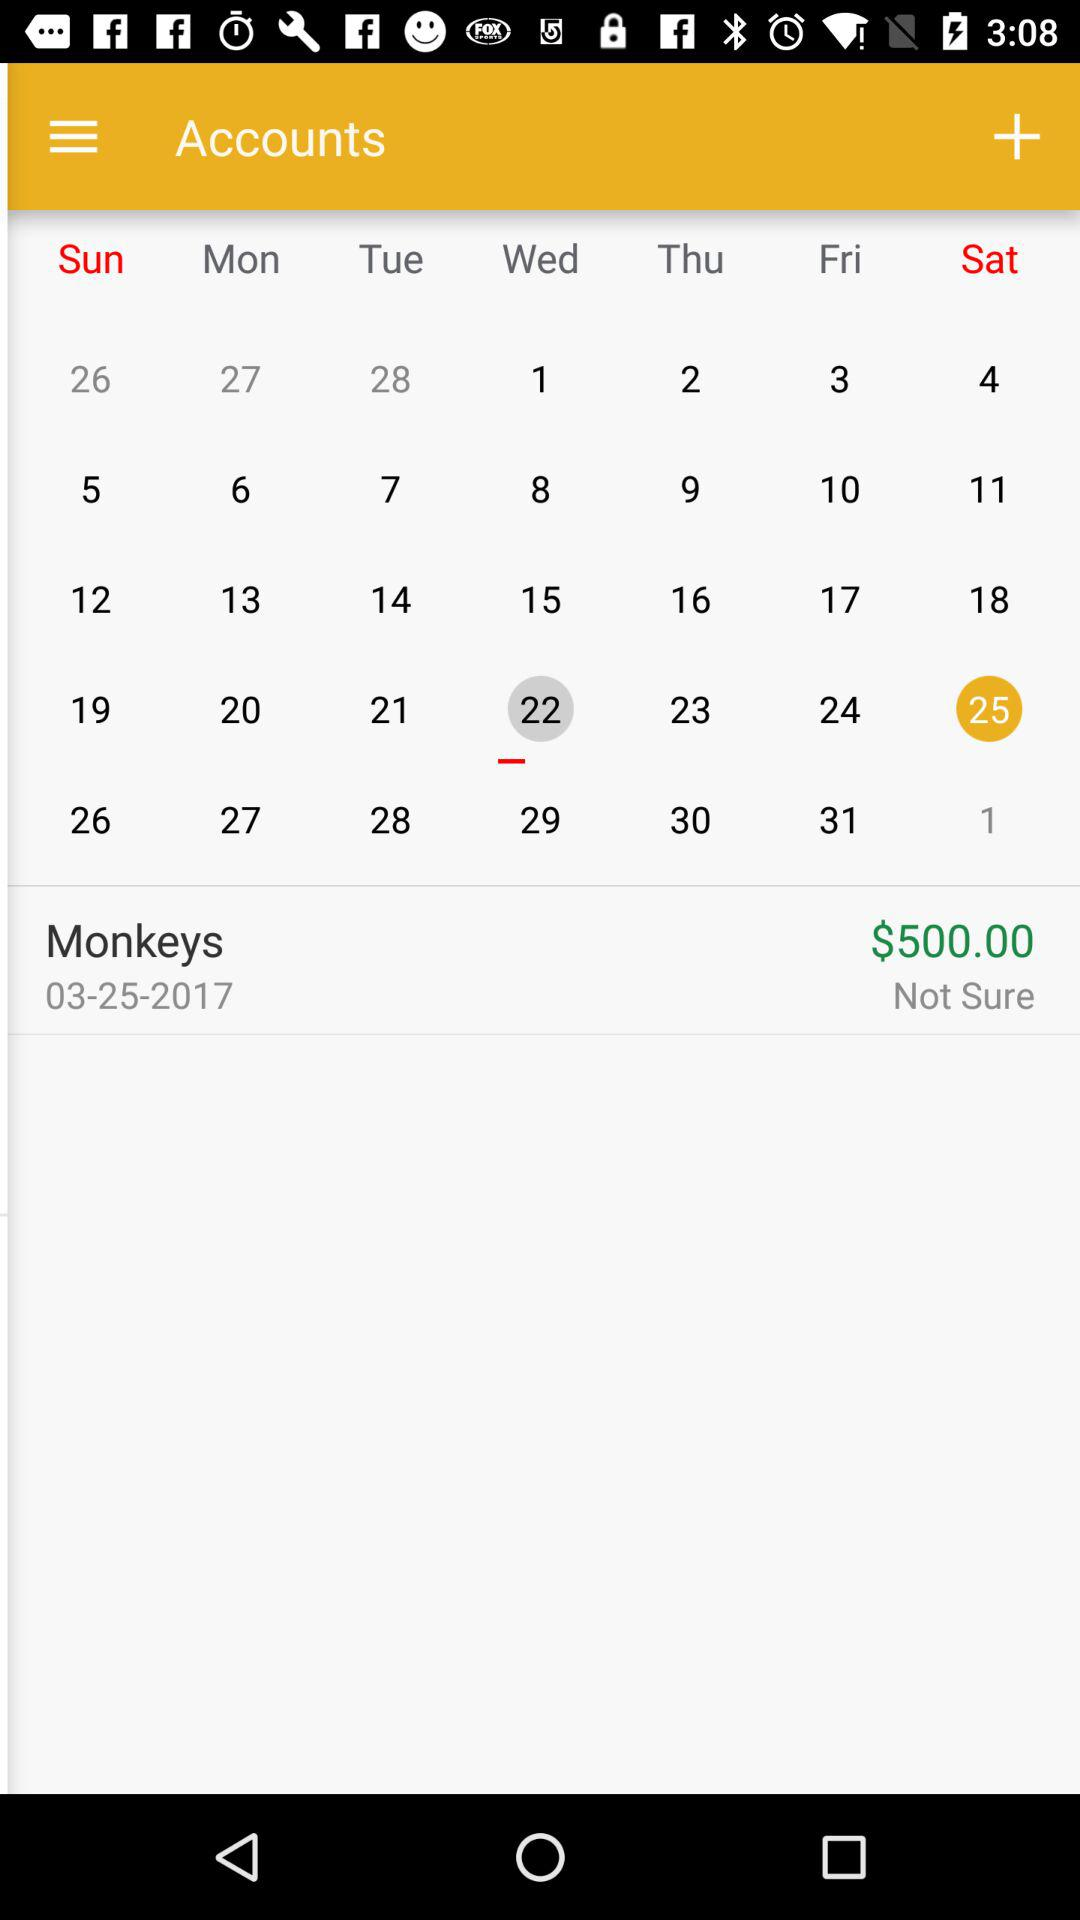What is the total amount of money spent on this transaction?
Answer the question using a single word or phrase. $500.00 